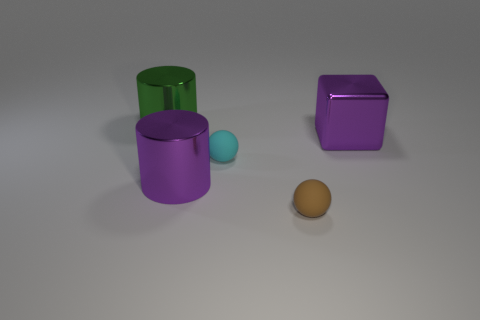Subtract all gray blocks. Subtract all yellow spheres. How many blocks are left? 1 Add 5 small cyan things. How many objects exist? 10 Subtract all blocks. How many objects are left? 4 Subtract 0 green cubes. How many objects are left? 5 Subtract all big purple things. Subtract all purple objects. How many objects are left? 1 Add 3 purple objects. How many purple objects are left? 5 Add 5 big blue matte spheres. How many big blue matte spheres exist? 5 